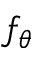<formula> <loc_0><loc_0><loc_500><loc_500>f _ { \theta }</formula> 